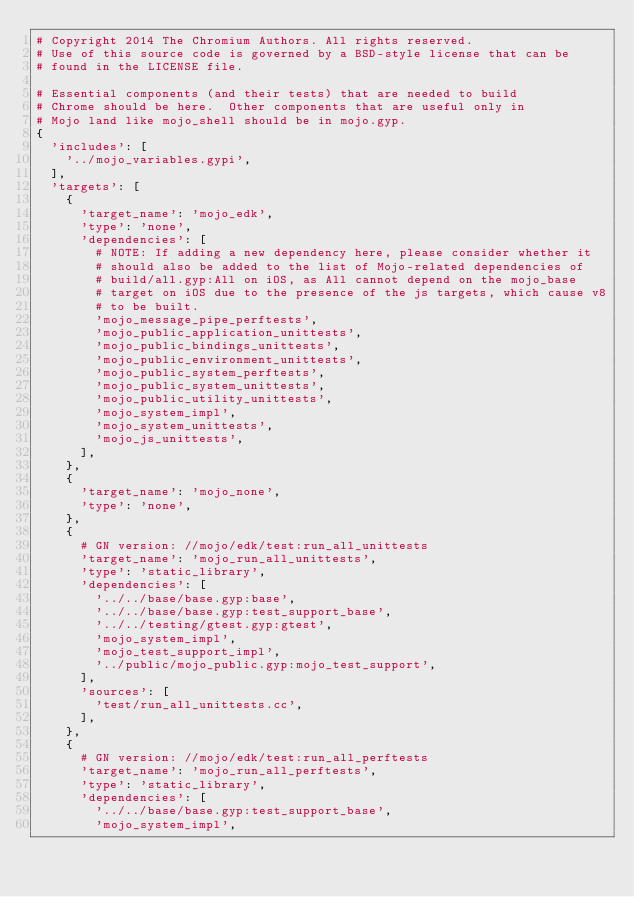Convert code to text. <code><loc_0><loc_0><loc_500><loc_500><_Python_># Copyright 2014 The Chromium Authors. All rights reserved.
# Use of this source code is governed by a BSD-style license that can be
# found in the LICENSE file.

# Essential components (and their tests) that are needed to build
# Chrome should be here.  Other components that are useful only in
# Mojo land like mojo_shell should be in mojo.gyp.
{
  'includes': [
    '../mojo_variables.gypi',
  ],
  'targets': [
    {
      'target_name': 'mojo_edk',
      'type': 'none',
      'dependencies': [
        # NOTE: If adding a new dependency here, please consider whether it
        # should also be added to the list of Mojo-related dependencies of
        # build/all.gyp:All on iOS, as All cannot depend on the mojo_base
        # target on iOS due to the presence of the js targets, which cause v8
        # to be built.
        'mojo_message_pipe_perftests',
        'mojo_public_application_unittests',
        'mojo_public_bindings_unittests',
        'mojo_public_environment_unittests',
        'mojo_public_system_perftests',
        'mojo_public_system_unittests',
        'mojo_public_utility_unittests',
        'mojo_system_impl',
        'mojo_system_unittests',
        'mojo_js_unittests',
      ],
    },
    {
      'target_name': 'mojo_none',
      'type': 'none',
    },
    {
      # GN version: //mojo/edk/test:run_all_unittests
      'target_name': 'mojo_run_all_unittests',
      'type': 'static_library',
      'dependencies': [
        '../../base/base.gyp:base',
        '../../base/base.gyp:test_support_base',
        '../../testing/gtest.gyp:gtest',
        'mojo_system_impl',
        'mojo_test_support_impl',
        '../public/mojo_public.gyp:mojo_test_support',
      ],
      'sources': [
        'test/run_all_unittests.cc',
      ],
    },
    {
      # GN version: //mojo/edk/test:run_all_perftests
      'target_name': 'mojo_run_all_perftests',
      'type': 'static_library',
      'dependencies': [
        '../../base/base.gyp:test_support_base',
        'mojo_system_impl',</code> 